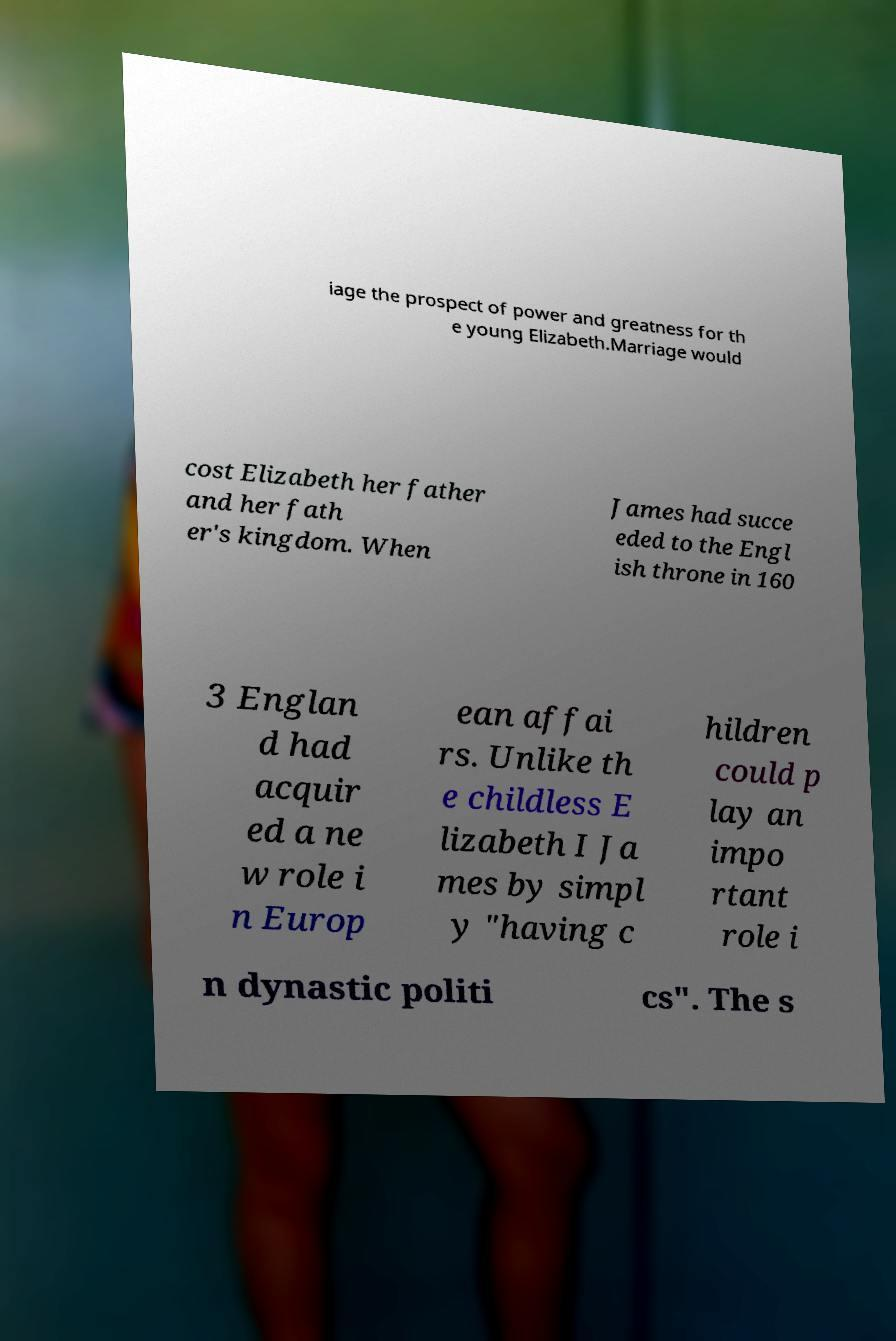What messages or text are displayed in this image? I need them in a readable, typed format. iage the prospect of power and greatness for th e young Elizabeth.Marriage would cost Elizabeth her father and her fath er's kingdom. When James had succe eded to the Engl ish throne in 160 3 Englan d had acquir ed a ne w role i n Europ ean affai rs. Unlike th e childless E lizabeth I Ja mes by simpl y "having c hildren could p lay an impo rtant role i n dynastic politi cs". The s 